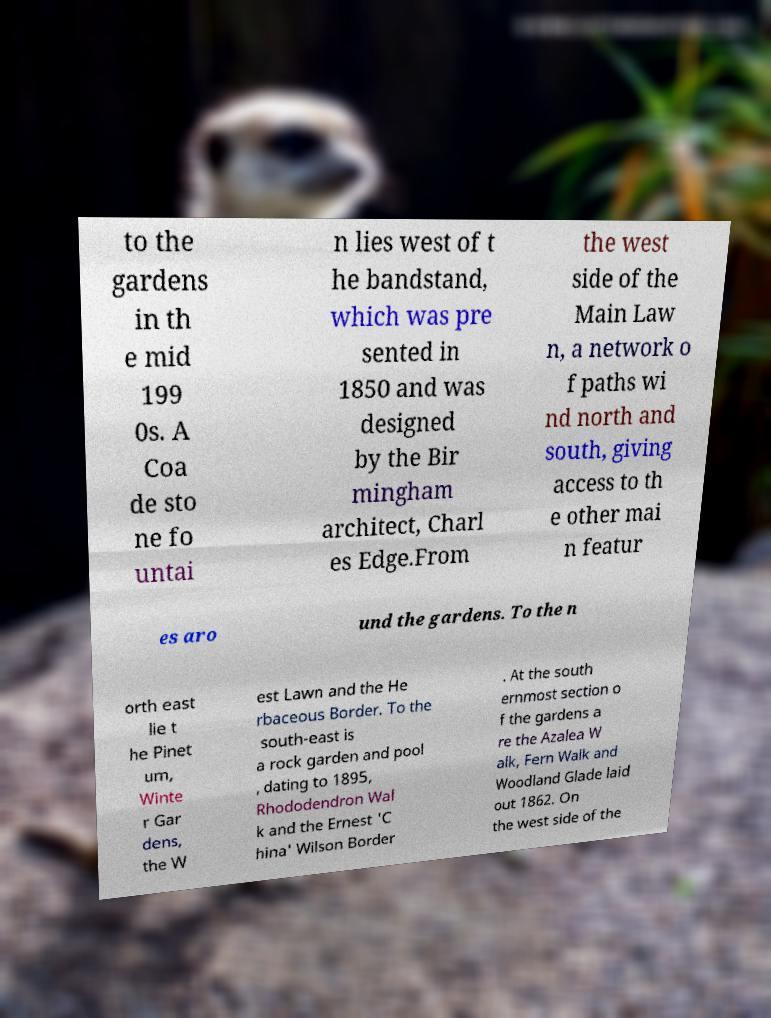I need the written content from this picture converted into text. Can you do that? to the gardens in th e mid 199 0s. A Coa de sto ne fo untai n lies west of t he bandstand, which was pre sented in 1850 and was designed by the Bir mingham architect, Charl es Edge.From the west side of the Main Law n, a network o f paths wi nd north and south, giving access to th e other mai n featur es aro und the gardens. To the n orth east lie t he Pinet um, Winte r Gar dens, the W est Lawn and the He rbaceous Border. To the south-east is a rock garden and pool , dating to 1895, Rhododendron Wal k and the Ernest 'C hina' Wilson Border . At the south ernmost section o f the gardens a re the Azalea W alk, Fern Walk and Woodland Glade laid out 1862. On the west side of the 